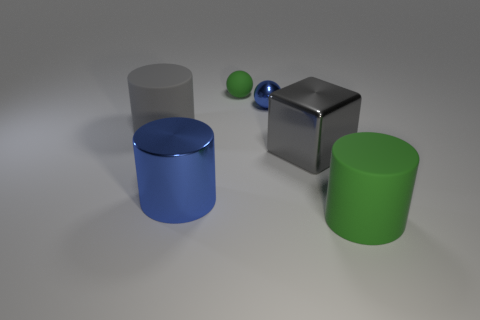What is the shape of the small green thing that is made of the same material as the gray cylinder?
Your answer should be compact. Sphere. What is the thing that is behind the big metallic block and to the left of the small green object made of?
Provide a succinct answer. Rubber. What is the shape of the thing that is behind the gray cylinder and in front of the green rubber sphere?
Offer a terse response. Sphere. Does the tiny green thing have the same material as the green thing in front of the gray cylinder?
Your response must be concise. Yes. Are any big cyan rubber cylinders visible?
Your answer should be compact. No. Is there a green object left of the green thing on the right side of the large shiny object that is to the right of the blue sphere?
Your answer should be compact. Yes. How many large things are either blue spheres or matte objects?
Ensure brevity in your answer.  2. What is the color of the shiny block that is the same size as the metal cylinder?
Give a very brief answer. Gray. There is a gray metallic object; what number of green objects are left of it?
Offer a very short reply. 1. Is there a big block that has the same material as the tiny green thing?
Offer a terse response. No. 